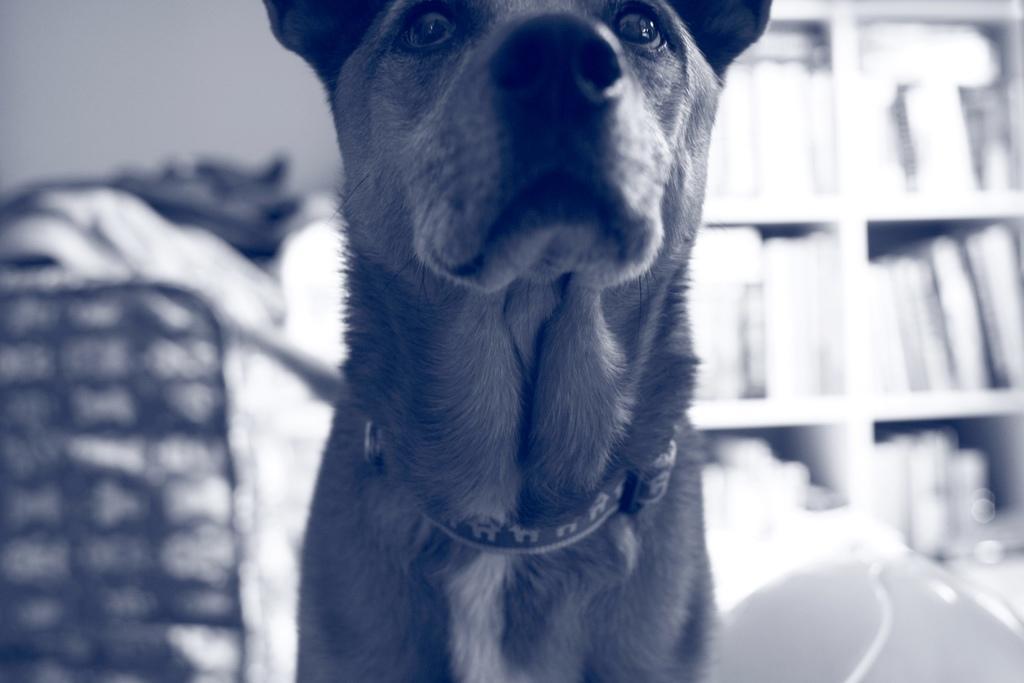Could you give a brief overview of what you see in this image? In this picture I can see in the middle there is a dog, this image is in black and white color. 